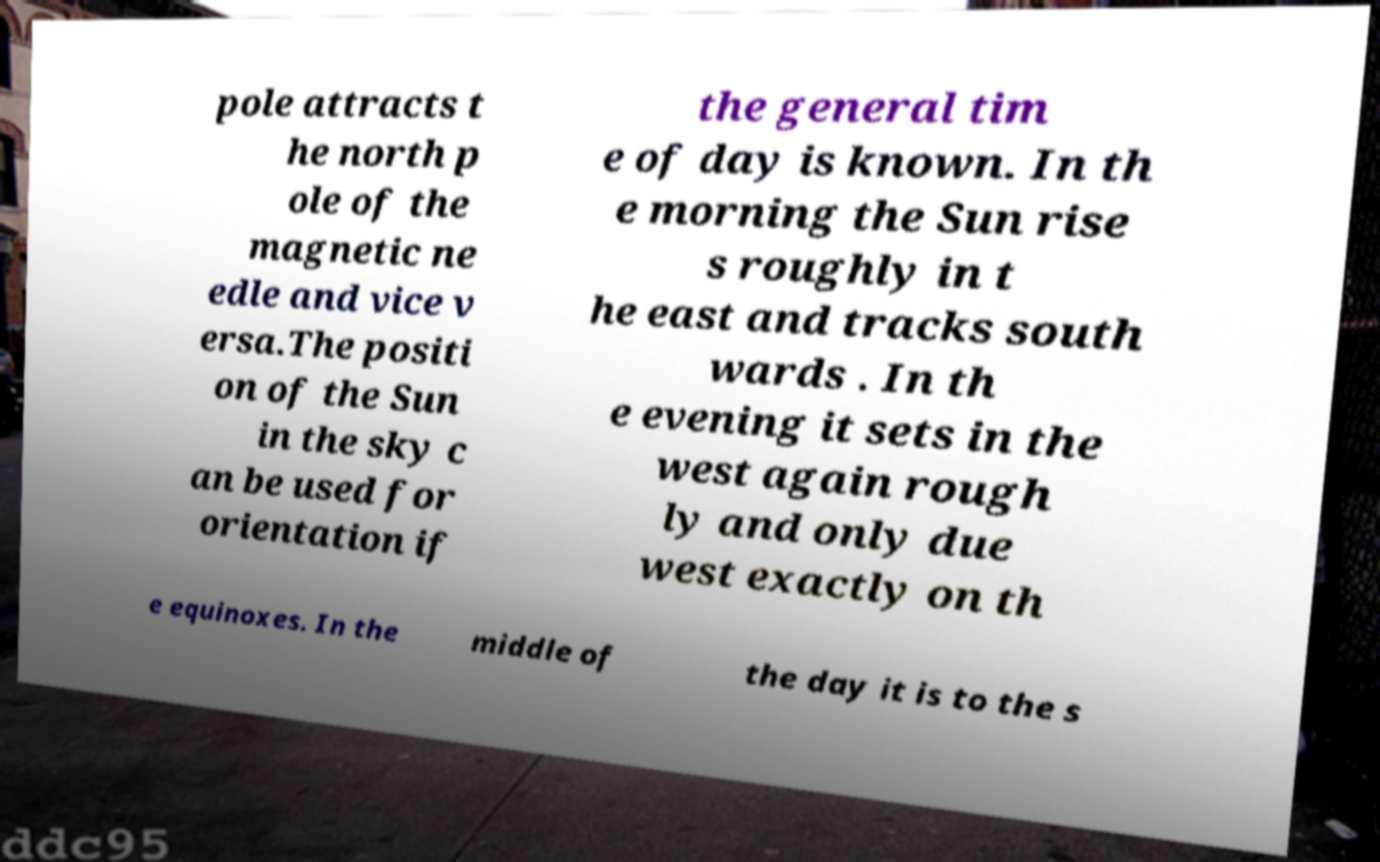Can you read and provide the text displayed in the image?This photo seems to have some interesting text. Can you extract and type it out for me? pole attracts t he north p ole of the magnetic ne edle and vice v ersa.The positi on of the Sun in the sky c an be used for orientation if the general tim e of day is known. In th e morning the Sun rise s roughly in t he east and tracks south wards . In th e evening it sets in the west again rough ly and only due west exactly on th e equinoxes. In the middle of the day it is to the s 